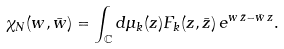<formula> <loc_0><loc_0><loc_500><loc_500>\chi _ { N } ( w , \bar { w } ) = \int _ { \mathbb { C } } d \mu _ { k } ( z ) F _ { k } ( z , \bar { z } ) \, e ^ { w \, \bar { z } - \bar { w } \, z } .</formula> 